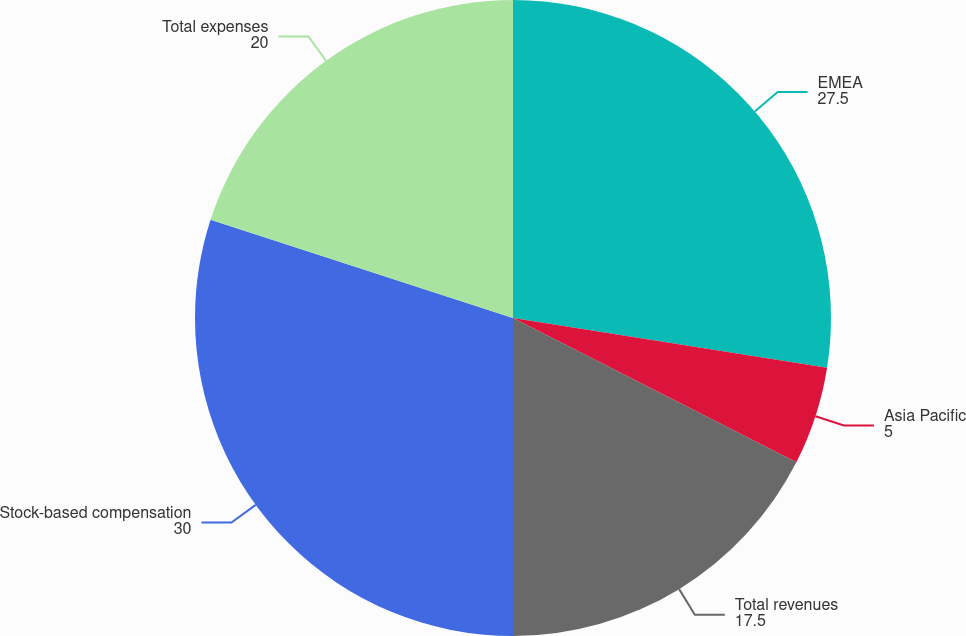Convert chart to OTSL. <chart><loc_0><loc_0><loc_500><loc_500><pie_chart><fcel>EMEA<fcel>Asia Pacific<fcel>Total revenues<fcel>Stock-based compensation<fcel>Total expenses<nl><fcel>27.5%<fcel>5.0%<fcel>17.5%<fcel>30.0%<fcel>20.0%<nl></chart> 